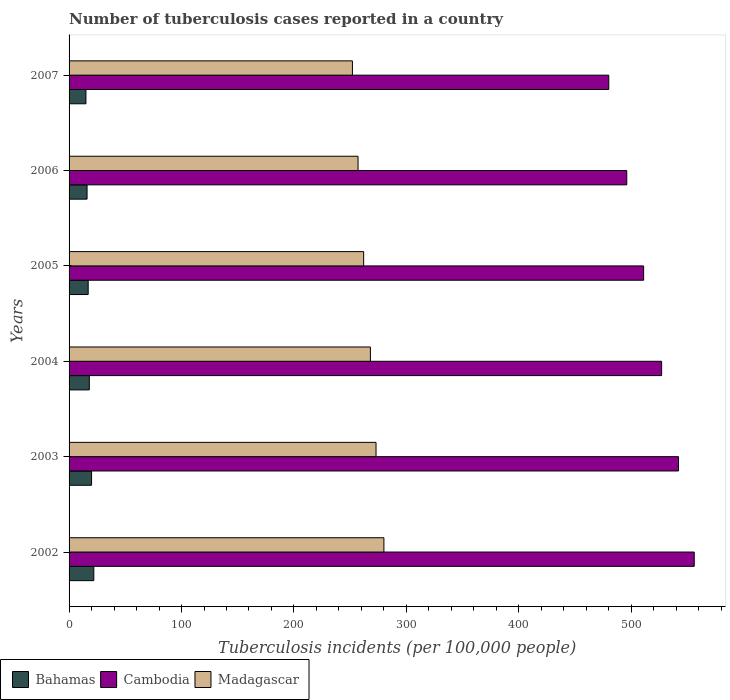How many different coloured bars are there?
Keep it short and to the point. 3. In how many cases, is the number of bars for a given year not equal to the number of legend labels?
Your response must be concise. 0. What is the number of tuberculosis cases reported in in Madagascar in 2007?
Your response must be concise. 252. Across all years, what is the maximum number of tuberculosis cases reported in in Madagascar?
Offer a very short reply. 280. Across all years, what is the minimum number of tuberculosis cases reported in in Madagascar?
Your answer should be compact. 252. In which year was the number of tuberculosis cases reported in in Madagascar maximum?
Offer a terse response. 2002. In which year was the number of tuberculosis cases reported in in Bahamas minimum?
Offer a terse response. 2007. What is the total number of tuberculosis cases reported in in Bahamas in the graph?
Make the answer very short. 108. What is the difference between the number of tuberculosis cases reported in in Cambodia in 2002 and that in 2007?
Provide a short and direct response. 76. What is the difference between the number of tuberculosis cases reported in in Bahamas in 2007 and the number of tuberculosis cases reported in in Cambodia in 2003?
Provide a short and direct response. -527. What is the average number of tuberculosis cases reported in in Madagascar per year?
Give a very brief answer. 265.33. In the year 2004, what is the difference between the number of tuberculosis cases reported in in Madagascar and number of tuberculosis cases reported in in Cambodia?
Provide a succinct answer. -259. In how many years, is the number of tuberculosis cases reported in in Madagascar greater than 260 ?
Provide a succinct answer. 4. What is the ratio of the number of tuberculosis cases reported in in Cambodia in 2002 to that in 2003?
Your answer should be very brief. 1.03. What is the difference between the highest and the second highest number of tuberculosis cases reported in in Madagascar?
Your response must be concise. 7. What is the difference between the highest and the lowest number of tuberculosis cases reported in in Cambodia?
Provide a short and direct response. 76. Is the sum of the number of tuberculosis cases reported in in Cambodia in 2002 and 2003 greater than the maximum number of tuberculosis cases reported in in Madagascar across all years?
Ensure brevity in your answer.  Yes. What does the 1st bar from the top in 2003 represents?
Keep it short and to the point. Madagascar. What does the 1st bar from the bottom in 2007 represents?
Ensure brevity in your answer.  Bahamas. Is it the case that in every year, the sum of the number of tuberculosis cases reported in in Bahamas and number of tuberculosis cases reported in in Madagascar is greater than the number of tuberculosis cases reported in in Cambodia?
Give a very brief answer. No. Are all the bars in the graph horizontal?
Offer a very short reply. Yes. How many years are there in the graph?
Your response must be concise. 6. Does the graph contain grids?
Offer a terse response. No. How many legend labels are there?
Keep it short and to the point. 3. What is the title of the graph?
Your response must be concise. Number of tuberculosis cases reported in a country. Does "Qatar" appear as one of the legend labels in the graph?
Make the answer very short. No. What is the label or title of the X-axis?
Your response must be concise. Tuberculosis incidents (per 100,0 people). What is the label or title of the Y-axis?
Your response must be concise. Years. What is the Tuberculosis incidents (per 100,000 people) of Bahamas in 2002?
Provide a succinct answer. 22. What is the Tuberculosis incidents (per 100,000 people) in Cambodia in 2002?
Offer a terse response. 556. What is the Tuberculosis incidents (per 100,000 people) of Madagascar in 2002?
Offer a very short reply. 280. What is the Tuberculosis incidents (per 100,000 people) in Bahamas in 2003?
Make the answer very short. 20. What is the Tuberculosis incidents (per 100,000 people) in Cambodia in 2003?
Provide a succinct answer. 542. What is the Tuberculosis incidents (per 100,000 people) in Madagascar in 2003?
Ensure brevity in your answer.  273. What is the Tuberculosis incidents (per 100,000 people) of Bahamas in 2004?
Provide a succinct answer. 18. What is the Tuberculosis incidents (per 100,000 people) of Cambodia in 2004?
Ensure brevity in your answer.  527. What is the Tuberculosis incidents (per 100,000 people) of Madagascar in 2004?
Give a very brief answer. 268. What is the Tuberculosis incidents (per 100,000 people) of Cambodia in 2005?
Keep it short and to the point. 511. What is the Tuberculosis incidents (per 100,000 people) of Madagascar in 2005?
Ensure brevity in your answer.  262. What is the Tuberculosis incidents (per 100,000 people) of Cambodia in 2006?
Provide a short and direct response. 496. What is the Tuberculosis incidents (per 100,000 people) of Madagascar in 2006?
Provide a succinct answer. 257. What is the Tuberculosis incidents (per 100,000 people) in Bahamas in 2007?
Make the answer very short. 15. What is the Tuberculosis incidents (per 100,000 people) of Cambodia in 2007?
Ensure brevity in your answer.  480. What is the Tuberculosis incidents (per 100,000 people) of Madagascar in 2007?
Make the answer very short. 252. Across all years, what is the maximum Tuberculosis incidents (per 100,000 people) of Bahamas?
Make the answer very short. 22. Across all years, what is the maximum Tuberculosis incidents (per 100,000 people) in Cambodia?
Your response must be concise. 556. Across all years, what is the maximum Tuberculosis incidents (per 100,000 people) in Madagascar?
Your response must be concise. 280. Across all years, what is the minimum Tuberculosis incidents (per 100,000 people) in Cambodia?
Provide a short and direct response. 480. Across all years, what is the minimum Tuberculosis incidents (per 100,000 people) in Madagascar?
Your response must be concise. 252. What is the total Tuberculosis incidents (per 100,000 people) of Bahamas in the graph?
Provide a short and direct response. 108. What is the total Tuberculosis incidents (per 100,000 people) in Cambodia in the graph?
Give a very brief answer. 3112. What is the total Tuberculosis incidents (per 100,000 people) of Madagascar in the graph?
Ensure brevity in your answer.  1592. What is the difference between the Tuberculosis incidents (per 100,000 people) of Bahamas in 2002 and that in 2003?
Your answer should be very brief. 2. What is the difference between the Tuberculosis incidents (per 100,000 people) of Cambodia in 2002 and that in 2003?
Provide a short and direct response. 14. What is the difference between the Tuberculosis incidents (per 100,000 people) in Madagascar in 2002 and that in 2003?
Ensure brevity in your answer.  7. What is the difference between the Tuberculosis incidents (per 100,000 people) in Bahamas in 2002 and that in 2004?
Offer a terse response. 4. What is the difference between the Tuberculosis incidents (per 100,000 people) of Cambodia in 2002 and that in 2004?
Provide a short and direct response. 29. What is the difference between the Tuberculosis incidents (per 100,000 people) of Madagascar in 2002 and that in 2004?
Your answer should be compact. 12. What is the difference between the Tuberculosis incidents (per 100,000 people) of Cambodia in 2002 and that in 2005?
Offer a very short reply. 45. What is the difference between the Tuberculosis incidents (per 100,000 people) in Cambodia in 2002 and that in 2006?
Offer a terse response. 60. What is the difference between the Tuberculosis incidents (per 100,000 people) of Madagascar in 2002 and that in 2006?
Provide a short and direct response. 23. What is the difference between the Tuberculosis incidents (per 100,000 people) in Cambodia in 2002 and that in 2007?
Your answer should be very brief. 76. What is the difference between the Tuberculosis incidents (per 100,000 people) in Madagascar in 2002 and that in 2007?
Offer a very short reply. 28. What is the difference between the Tuberculosis incidents (per 100,000 people) of Cambodia in 2003 and that in 2004?
Give a very brief answer. 15. What is the difference between the Tuberculosis incidents (per 100,000 people) of Madagascar in 2003 and that in 2004?
Provide a short and direct response. 5. What is the difference between the Tuberculosis incidents (per 100,000 people) in Madagascar in 2003 and that in 2005?
Your answer should be very brief. 11. What is the difference between the Tuberculosis incidents (per 100,000 people) of Bahamas in 2003 and that in 2006?
Your answer should be compact. 4. What is the difference between the Tuberculosis incidents (per 100,000 people) in Madagascar in 2003 and that in 2006?
Give a very brief answer. 16. What is the difference between the Tuberculosis incidents (per 100,000 people) in Bahamas in 2003 and that in 2007?
Give a very brief answer. 5. What is the difference between the Tuberculosis incidents (per 100,000 people) of Cambodia in 2003 and that in 2007?
Your answer should be very brief. 62. What is the difference between the Tuberculosis incidents (per 100,000 people) of Madagascar in 2003 and that in 2007?
Provide a succinct answer. 21. What is the difference between the Tuberculosis incidents (per 100,000 people) of Bahamas in 2004 and that in 2006?
Ensure brevity in your answer.  2. What is the difference between the Tuberculosis incidents (per 100,000 people) of Bahamas in 2004 and that in 2007?
Your response must be concise. 3. What is the difference between the Tuberculosis incidents (per 100,000 people) in Madagascar in 2004 and that in 2007?
Your answer should be very brief. 16. What is the difference between the Tuberculosis incidents (per 100,000 people) of Bahamas in 2005 and that in 2006?
Provide a short and direct response. 1. What is the difference between the Tuberculosis incidents (per 100,000 people) of Cambodia in 2005 and that in 2007?
Give a very brief answer. 31. What is the difference between the Tuberculosis incidents (per 100,000 people) in Madagascar in 2005 and that in 2007?
Offer a terse response. 10. What is the difference between the Tuberculosis incidents (per 100,000 people) in Madagascar in 2006 and that in 2007?
Keep it short and to the point. 5. What is the difference between the Tuberculosis incidents (per 100,000 people) in Bahamas in 2002 and the Tuberculosis incidents (per 100,000 people) in Cambodia in 2003?
Make the answer very short. -520. What is the difference between the Tuberculosis incidents (per 100,000 people) of Bahamas in 2002 and the Tuberculosis incidents (per 100,000 people) of Madagascar in 2003?
Make the answer very short. -251. What is the difference between the Tuberculosis incidents (per 100,000 people) in Cambodia in 2002 and the Tuberculosis incidents (per 100,000 people) in Madagascar in 2003?
Offer a very short reply. 283. What is the difference between the Tuberculosis incidents (per 100,000 people) of Bahamas in 2002 and the Tuberculosis incidents (per 100,000 people) of Cambodia in 2004?
Ensure brevity in your answer.  -505. What is the difference between the Tuberculosis incidents (per 100,000 people) in Bahamas in 2002 and the Tuberculosis incidents (per 100,000 people) in Madagascar in 2004?
Your response must be concise. -246. What is the difference between the Tuberculosis incidents (per 100,000 people) of Cambodia in 2002 and the Tuberculosis incidents (per 100,000 people) of Madagascar in 2004?
Your answer should be very brief. 288. What is the difference between the Tuberculosis incidents (per 100,000 people) in Bahamas in 2002 and the Tuberculosis incidents (per 100,000 people) in Cambodia in 2005?
Your response must be concise. -489. What is the difference between the Tuberculosis incidents (per 100,000 people) of Bahamas in 2002 and the Tuberculosis incidents (per 100,000 people) of Madagascar in 2005?
Your response must be concise. -240. What is the difference between the Tuberculosis incidents (per 100,000 people) of Cambodia in 2002 and the Tuberculosis incidents (per 100,000 people) of Madagascar in 2005?
Your answer should be very brief. 294. What is the difference between the Tuberculosis incidents (per 100,000 people) of Bahamas in 2002 and the Tuberculosis incidents (per 100,000 people) of Cambodia in 2006?
Give a very brief answer. -474. What is the difference between the Tuberculosis incidents (per 100,000 people) of Bahamas in 2002 and the Tuberculosis incidents (per 100,000 people) of Madagascar in 2006?
Offer a very short reply. -235. What is the difference between the Tuberculosis incidents (per 100,000 people) of Cambodia in 2002 and the Tuberculosis incidents (per 100,000 people) of Madagascar in 2006?
Your answer should be compact. 299. What is the difference between the Tuberculosis incidents (per 100,000 people) in Bahamas in 2002 and the Tuberculosis incidents (per 100,000 people) in Cambodia in 2007?
Offer a terse response. -458. What is the difference between the Tuberculosis incidents (per 100,000 people) in Bahamas in 2002 and the Tuberculosis incidents (per 100,000 people) in Madagascar in 2007?
Your response must be concise. -230. What is the difference between the Tuberculosis incidents (per 100,000 people) in Cambodia in 2002 and the Tuberculosis incidents (per 100,000 people) in Madagascar in 2007?
Your response must be concise. 304. What is the difference between the Tuberculosis incidents (per 100,000 people) of Bahamas in 2003 and the Tuberculosis incidents (per 100,000 people) of Cambodia in 2004?
Provide a short and direct response. -507. What is the difference between the Tuberculosis incidents (per 100,000 people) of Bahamas in 2003 and the Tuberculosis incidents (per 100,000 people) of Madagascar in 2004?
Your response must be concise. -248. What is the difference between the Tuberculosis incidents (per 100,000 people) of Cambodia in 2003 and the Tuberculosis incidents (per 100,000 people) of Madagascar in 2004?
Your answer should be very brief. 274. What is the difference between the Tuberculosis incidents (per 100,000 people) in Bahamas in 2003 and the Tuberculosis incidents (per 100,000 people) in Cambodia in 2005?
Provide a succinct answer. -491. What is the difference between the Tuberculosis incidents (per 100,000 people) in Bahamas in 2003 and the Tuberculosis incidents (per 100,000 people) in Madagascar in 2005?
Give a very brief answer. -242. What is the difference between the Tuberculosis incidents (per 100,000 people) of Cambodia in 2003 and the Tuberculosis incidents (per 100,000 people) of Madagascar in 2005?
Provide a short and direct response. 280. What is the difference between the Tuberculosis incidents (per 100,000 people) in Bahamas in 2003 and the Tuberculosis incidents (per 100,000 people) in Cambodia in 2006?
Ensure brevity in your answer.  -476. What is the difference between the Tuberculosis incidents (per 100,000 people) of Bahamas in 2003 and the Tuberculosis incidents (per 100,000 people) of Madagascar in 2006?
Give a very brief answer. -237. What is the difference between the Tuberculosis incidents (per 100,000 people) of Cambodia in 2003 and the Tuberculosis incidents (per 100,000 people) of Madagascar in 2006?
Your response must be concise. 285. What is the difference between the Tuberculosis incidents (per 100,000 people) in Bahamas in 2003 and the Tuberculosis incidents (per 100,000 people) in Cambodia in 2007?
Provide a short and direct response. -460. What is the difference between the Tuberculosis incidents (per 100,000 people) of Bahamas in 2003 and the Tuberculosis incidents (per 100,000 people) of Madagascar in 2007?
Make the answer very short. -232. What is the difference between the Tuberculosis incidents (per 100,000 people) of Cambodia in 2003 and the Tuberculosis incidents (per 100,000 people) of Madagascar in 2007?
Your answer should be compact. 290. What is the difference between the Tuberculosis incidents (per 100,000 people) of Bahamas in 2004 and the Tuberculosis incidents (per 100,000 people) of Cambodia in 2005?
Provide a short and direct response. -493. What is the difference between the Tuberculosis incidents (per 100,000 people) in Bahamas in 2004 and the Tuberculosis incidents (per 100,000 people) in Madagascar in 2005?
Your answer should be very brief. -244. What is the difference between the Tuberculosis incidents (per 100,000 people) of Cambodia in 2004 and the Tuberculosis incidents (per 100,000 people) of Madagascar in 2005?
Keep it short and to the point. 265. What is the difference between the Tuberculosis incidents (per 100,000 people) of Bahamas in 2004 and the Tuberculosis incidents (per 100,000 people) of Cambodia in 2006?
Offer a very short reply. -478. What is the difference between the Tuberculosis incidents (per 100,000 people) in Bahamas in 2004 and the Tuberculosis incidents (per 100,000 people) in Madagascar in 2006?
Your response must be concise. -239. What is the difference between the Tuberculosis incidents (per 100,000 people) of Cambodia in 2004 and the Tuberculosis incidents (per 100,000 people) of Madagascar in 2006?
Ensure brevity in your answer.  270. What is the difference between the Tuberculosis incidents (per 100,000 people) of Bahamas in 2004 and the Tuberculosis incidents (per 100,000 people) of Cambodia in 2007?
Provide a succinct answer. -462. What is the difference between the Tuberculosis incidents (per 100,000 people) in Bahamas in 2004 and the Tuberculosis incidents (per 100,000 people) in Madagascar in 2007?
Your answer should be compact. -234. What is the difference between the Tuberculosis incidents (per 100,000 people) in Cambodia in 2004 and the Tuberculosis incidents (per 100,000 people) in Madagascar in 2007?
Provide a short and direct response. 275. What is the difference between the Tuberculosis incidents (per 100,000 people) of Bahamas in 2005 and the Tuberculosis incidents (per 100,000 people) of Cambodia in 2006?
Give a very brief answer. -479. What is the difference between the Tuberculosis incidents (per 100,000 people) of Bahamas in 2005 and the Tuberculosis incidents (per 100,000 people) of Madagascar in 2006?
Offer a very short reply. -240. What is the difference between the Tuberculosis incidents (per 100,000 people) in Cambodia in 2005 and the Tuberculosis incidents (per 100,000 people) in Madagascar in 2006?
Make the answer very short. 254. What is the difference between the Tuberculosis incidents (per 100,000 people) in Bahamas in 2005 and the Tuberculosis incidents (per 100,000 people) in Cambodia in 2007?
Keep it short and to the point. -463. What is the difference between the Tuberculosis incidents (per 100,000 people) of Bahamas in 2005 and the Tuberculosis incidents (per 100,000 people) of Madagascar in 2007?
Your answer should be very brief. -235. What is the difference between the Tuberculosis incidents (per 100,000 people) of Cambodia in 2005 and the Tuberculosis incidents (per 100,000 people) of Madagascar in 2007?
Provide a short and direct response. 259. What is the difference between the Tuberculosis incidents (per 100,000 people) in Bahamas in 2006 and the Tuberculosis incidents (per 100,000 people) in Cambodia in 2007?
Your response must be concise. -464. What is the difference between the Tuberculosis incidents (per 100,000 people) of Bahamas in 2006 and the Tuberculosis incidents (per 100,000 people) of Madagascar in 2007?
Offer a very short reply. -236. What is the difference between the Tuberculosis incidents (per 100,000 people) of Cambodia in 2006 and the Tuberculosis incidents (per 100,000 people) of Madagascar in 2007?
Your response must be concise. 244. What is the average Tuberculosis incidents (per 100,000 people) of Bahamas per year?
Offer a terse response. 18. What is the average Tuberculosis incidents (per 100,000 people) in Cambodia per year?
Your response must be concise. 518.67. What is the average Tuberculosis incidents (per 100,000 people) of Madagascar per year?
Provide a succinct answer. 265.33. In the year 2002, what is the difference between the Tuberculosis incidents (per 100,000 people) in Bahamas and Tuberculosis incidents (per 100,000 people) in Cambodia?
Keep it short and to the point. -534. In the year 2002, what is the difference between the Tuberculosis incidents (per 100,000 people) in Bahamas and Tuberculosis incidents (per 100,000 people) in Madagascar?
Your answer should be compact. -258. In the year 2002, what is the difference between the Tuberculosis incidents (per 100,000 people) of Cambodia and Tuberculosis incidents (per 100,000 people) of Madagascar?
Offer a terse response. 276. In the year 2003, what is the difference between the Tuberculosis incidents (per 100,000 people) in Bahamas and Tuberculosis incidents (per 100,000 people) in Cambodia?
Provide a succinct answer. -522. In the year 2003, what is the difference between the Tuberculosis incidents (per 100,000 people) of Bahamas and Tuberculosis incidents (per 100,000 people) of Madagascar?
Offer a very short reply. -253. In the year 2003, what is the difference between the Tuberculosis incidents (per 100,000 people) in Cambodia and Tuberculosis incidents (per 100,000 people) in Madagascar?
Provide a short and direct response. 269. In the year 2004, what is the difference between the Tuberculosis incidents (per 100,000 people) of Bahamas and Tuberculosis incidents (per 100,000 people) of Cambodia?
Provide a short and direct response. -509. In the year 2004, what is the difference between the Tuberculosis incidents (per 100,000 people) in Bahamas and Tuberculosis incidents (per 100,000 people) in Madagascar?
Keep it short and to the point. -250. In the year 2004, what is the difference between the Tuberculosis incidents (per 100,000 people) of Cambodia and Tuberculosis incidents (per 100,000 people) of Madagascar?
Provide a short and direct response. 259. In the year 2005, what is the difference between the Tuberculosis incidents (per 100,000 people) in Bahamas and Tuberculosis incidents (per 100,000 people) in Cambodia?
Ensure brevity in your answer.  -494. In the year 2005, what is the difference between the Tuberculosis incidents (per 100,000 people) in Bahamas and Tuberculosis incidents (per 100,000 people) in Madagascar?
Your answer should be compact. -245. In the year 2005, what is the difference between the Tuberculosis incidents (per 100,000 people) in Cambodia and Tuberculosis incidents (per 100,000 people) in Madagascar?
Make the answer very short. 249. In the year 2006, what is the difference between the Tuberculosis incidents (per 100,000 people) of Bahamas and Tuberculosis incidents (per 100,000 people) of Cambodia?
Ensure brevity in your answer.  -480. In the year 2006, what is the difference between the Tuberculosis incidents (per 100,000 people) in Bahamas and Tuberculosis incidents (per 100,000 people) in Madagascar?
Make the answer very short. -241. In the year 2006, what is the difference between the Tuberculosis incidents (per 100,000 people) in Cambodia and Tuberculosis incidents (per 100,000 people) in Madagascar?
Make the answer very short. 239. In the year 2007, what is the difference between the Tuberculosis incidents (per 100,000 people) in Bahamas and Tuberculosis incidents (per 100,000 people) in Cambodia?
Your answer should be very brief. -465. In the year 2007, what is the difference between the Tuberculosis incidents (per 100,000 people) of Bahamas and Tuberculosis incidents (per 100,000 people) of Madagascar?
Provide a succinct answer. -237. In the year 2007, what is the difference between the Tuberculosis incidents (per 100,000 people) in Cambodia and Tuberculosis incidents (per 100,000 people) in Madagascar?
Keep it short and to the point. 228. What is the ratio of the Tuberculosis incidents (per 100,000 people) in Bahamas in 2002 to that in 2003?
Your response must be concise. 1.1. What is the ratio of the Tuberculosis incidents (per 100,000 people) in Cambodia in 2002 to that in 2003?
Provide a succinct answer. 1.03. What is the ratio of the Tuberculosis incidents (per 100,000 people) in Madagascar in 2002 to that in 2003?
Provide a succinct answer. 1.03. What is the ratio of the Tuberculosis incidents (per 100,000 people) in Bahamas in 2002 to that in 2004?
Make the answer very short. 1.22. What is the ratio of the Tuberculosis incidents (per 100,000 people) of Cambodia in 2002 to that in 2004?
Your answer should be very brief. 1.05. What is the ratio of the Tuberculosis incidents (per 100,000 people) in Madagascar in 2002 to that in 2004?
Your answer should be compact. 1.04. What is the ratio of the Tuberculosis incidents (per 100,000 people) of Bahamas in 2002 to that in 2005?
Ensure brevity in your answer.  1.29. What is the ratio of the Tuberculosis incidents (per 100,000 people) of Cambodia in 2002 to that in 2005?
Ensure brevity in your answer.  1.09. What is the ratio of the Tuberculosis incidents (per 100,000 people) of Madagascar in 2002 to that in 2005?
Your answer should be compact. 1.07. What is the ratio of the Tuberculosis incidents (per 100,000 people) in Bahamas in 2002 to that in 2006?
Keep it short and to the point. 1.38. What is the ratio of the Tuberculosis incidents (per 100,000 people) of Cambodia in 2002 to that in 2006?
Keep it short and to the point. 1.12. What is the ratio of the Tuberculosis incidents (per 100,000 people) in Madagascar in 2002 to that in 2006?
Your answer should be compact. 1.09. What is the ratio of the Tuberculosis incidents (per 100,000 people) in Bahamas in 2002 to that in 2007?
Ensure brevity in your answer.  1.47. What is the ratio of the Tuberculosis incidents (per 100,000 people) in Cambodia in 2002 to that in 2007?
Your answer should be compact. 1.16. What is the ratio of the Tuberculosis incidents (per 100,000 people) in Madagascar in 2002 to that in 2007?
Your response must be concise. 1.11. What is the ratio of the Tuberculosis incidents (per 100,000 people) of Bahamas in 2003 to that in 2004?
Offer a terse response. 1.11. What is the ratio of the Tuberculosis incidents (per 100,000 people) in Cambodia in 2003 to that in 2004?
Offer a very short reply. 1.03. What is the ratio of the Tuberculosis incidents (per 100,000 people) of Madagascar in 2003 to that in 2004?
Provide a short and direct response. 1.02. What is the ratio of the Tuberculosis incidents (per 100,000 people) in Bahamas in 2003 to that in 2005?
Offer a terse response. 1.18. What is the ratio of the Tuberculosis incidents (per 100,000 people) of Cambodia in 2003 to that in 2005?
Your answer should be compact. 1.06. What is the ratio of the Tuberculosis incidents (per 100,000 people) in Madagascar in 2003 to that in 2005?
Offer a very short reply. 1.04. What is the ratio of the Tuberculosis incidents (per 100,000 people) in Bahamas in 2003 to that in 2006?
Offer a terse response. 1.25. What is the ratio of the Tuberculosis incidents (per 100,000 people) in Cambodia in 2003 to that in 2006?
Your answer should be compact. 1.09. What is the ratio of the Tuberculosis incidents (per 100,000 people) in Madagascar in 2003 to that in 2006?
Offer a very short reply. 1.06. What is the ratio of the Tuberculosis incidents (per 100,000 people) of Bahamas in 2003 to that in 2007?
Your response must be concise. 1.33. What is the ratio of the Tuberculosis incidents (per 100,000 people) in Cambodia in 2003 to that in 2007?
Make the answer very short. 1.13. What is the ratio of the Tuberculosis incidents (per 100,000 people) of Madagascar in 2003 to that in 2007?
Give a very brief answer. 1.08. What is the ratio of the Tuberculosis incidents (per 100,000 people) in Bahamas in 2004 to that in 2005?
Offer a terse response. 1.06. What is the ratio of the Tuberculosis incidents (per 100,000 people) in Cambodia in 2004 to that in 2005?
Ensure brevity in your answer.  1.03. What is the ratio of the Tuberculosis incidents (per 100,000 people) in Madagascar in 2004 to that in 2005?
Offer a terse response. 1.02. What is the ratio of the Tuberculosis incidents (per 100,000 people) of Bahamas in 2004 to that in 2006?
Offer a terse response. 1.12. What is the ratio of the Tuberculosis incidents (per 100,000 people) of Cambodia in 2004 to that in 2006?
Provide a short and direct response. 1.06. What is the ratio of the Tuberculosis incidents (per 100,000 people) in Madagascar in 2004 to that in 2006?
Your response must be concise. 1.04. What is the ratio of the Tuberculosis incidents (per 100,000 people) in Bahamas in 2004 to that in 2007?
Provide a succinct answer. 1.2. What is the ratio of the Tuberculosis incidents (per 100,000 people) of Cambodia in 2004 to that in 2007?
Provide a succinct answer. 1.1. What is the ratio of the Tuberculosis incidents (per 100,000 people) in Madagascar in 2004 to that in 2007?
Provide a short and direct response. 1.06. What is the ratio of the Tuberculosis incidents (per 100,000 people) in Cambodia in 2005 to that in 2006?
Your answer should be compact. 1.03. What is the ratio of the Tuberculosis incidents (per 100,000 people) in Madagascar in 2005 to that in 2006?
Give a very brief answer. 1.02. What is the ratio of the Tuberculosis incidents (per 100,000 people) in Bahamas in 2005 to that in 2007?
Keep it short and to the point. 1.13. What is the ratio of the Tuberculosis incidents (per 100,000 people) in Cambodia in 2005 to that in 2007?
Ensure brevity in your answer.  1.06. What is the ratio of the Tuberculosis incidents (per 100,000 people) in Madagascar in 2005 to that in 2007?
Give a very brief answer. 1.04. What is the ratio of the Tuberculosis incidents (per 100,000 people) in Bahamas in 2006 to that in 2007?
Provide a short and direct response. 1.07. What is the ratio of the Tuberculosis incidents (per 100,000 people) in Cambodia in 2006 to that in 2007?
Keep it short and to the point. 1.03. What is the ratio of the Tuberculosis incidents (per 100,000 people) of Madagascar in 2006 to that in 2007?
Make the answer very short. 1.02. What is the difference between the highest and the second highest Tuberculosis incidents (per 100,000 people) in Madagascar?
Your answer should be compact. 7. What is the difference between the highest and the lowest Tuberculosis incidents (per 100,000 people) of Cambodia?
Your answer should be compact. 76. What is the difference between the highest and the lowest Tuberculosis incidents (per 100,000 people) of Madagascar?
Your answer should be compact. 28. 